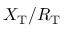Convert formula to latex. <formula><loc_0><loc_0><loc_500><loc_500>X _ { T } / R _ { T }</formula> 